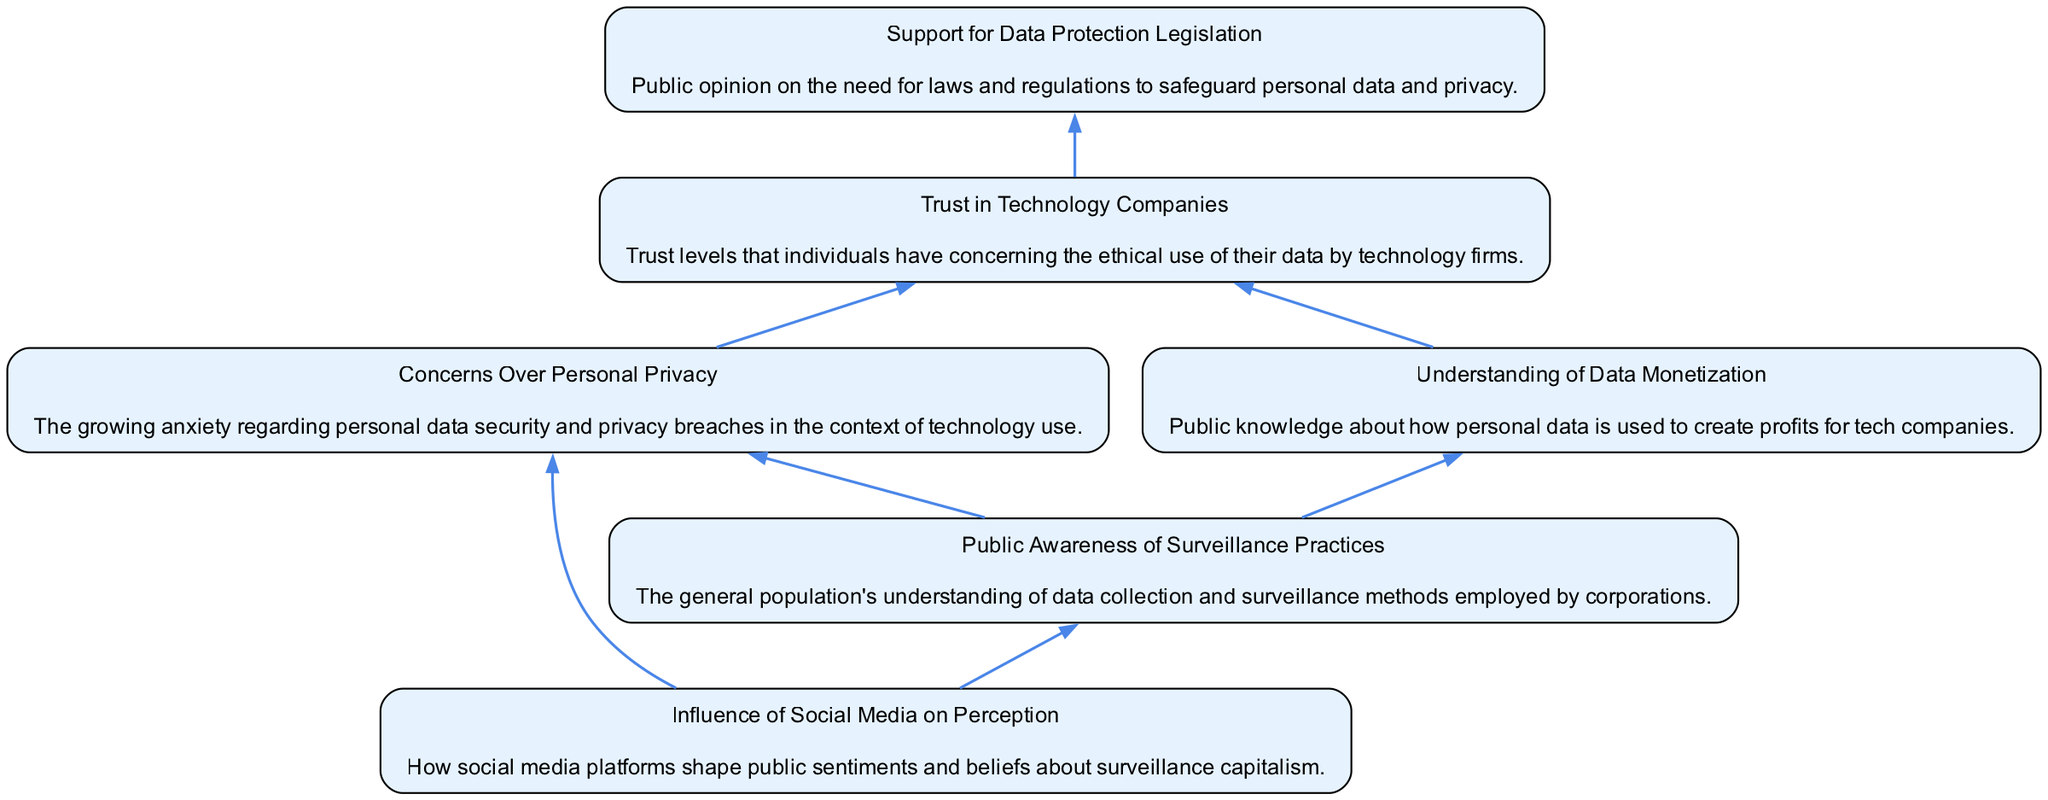What is the first node in the diagram? The diagram starts from "Public Awareness of Surveillance Practices," which acts as the initial node from which other nodes branch out.
Answer: Public Awareness of Surveillance Practices How many nodes are present in the diagram? Counting all unique elements listed in the diagram, there are six nodes labeled "Public Awareness," "Concerns Over Personal Privacy," "Understanding of Data Monetization," "Trust in Technology Companies," "Support for Data Protection Legislation," and "Influence of Social Media on Perception."
Answer: 6 Which node is directly influenced by both "Public Awareness" and "Social Media Influence"? The node "Concerns Over Personal Privacy" is influenced by both "Public Awareness" and "Social Media Influence," as both edges lead to this node indicating a direct relationship.
Answer: Concerns Over Personal Privacy Which two nodes lead to "Trust in Technology Companies"? The nodes "Concerns Over Personal Privacy" and "Understanding of Data Monetization" both lead to "Trust in Technology Companies," indicating that these elements contribute to trust levels in tech firms.
Answer: Concerns Over Personal Privacy and Understanding of Data Monetization What is the final node that indicates public opinion? The final node in the flow is "Support for Data Protection Legislation," which represents the result of the flow of public opinion regarding surveillance practices leading towards data protection laws.
Answer: Support for Data Protection Legislation How many edges connect to "Trust in Technology Companies"? There are three edges that connect to "Trust in Technology Companies": one from "Concerns Over Personal Privacy," one from "Understanding of Data Monetization," and one leading to "Support for Data Protection Legislation."
Answer: 3 Which node do "Concerns Over Personal Privacy" and "Understanding of Data Monetization" both connect to? Both nodes connect to "Trust in Technology Companies," indicating that the public's privacy concerns and their understanding of data monetization influence their trust in tech companies.
Answer: Trust in Technology Companies What is the significance of "Influence of Social Media on Perception" in the diagram? "Influence of Social Media on Perception" serves as an important node affecting both "Public Awareness" and "Concerns Over Personal Privacy," suggesting that social media plays a critical role in shaping public views on surveillance capitalism practices.
Answer: Influencing factor 